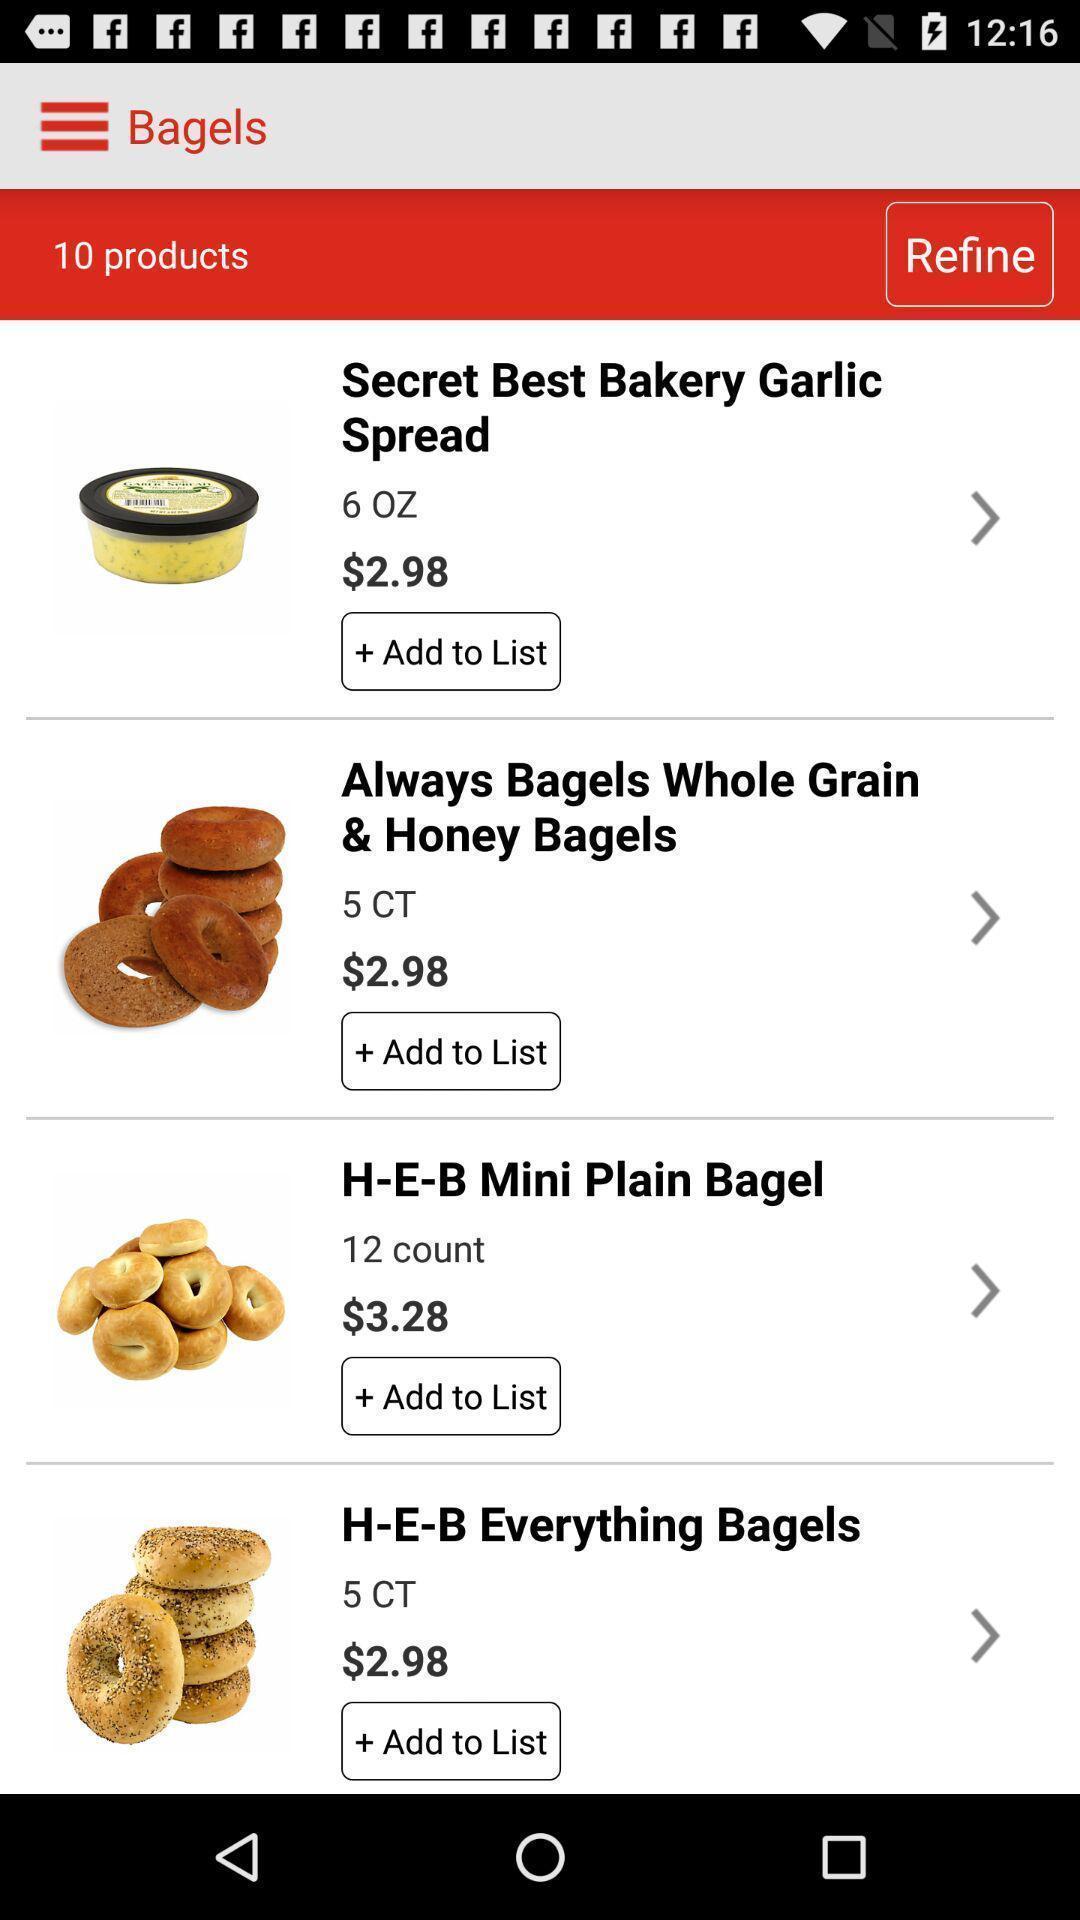What details can you identify in this image? Page displaying list of products with price in shopping application. 